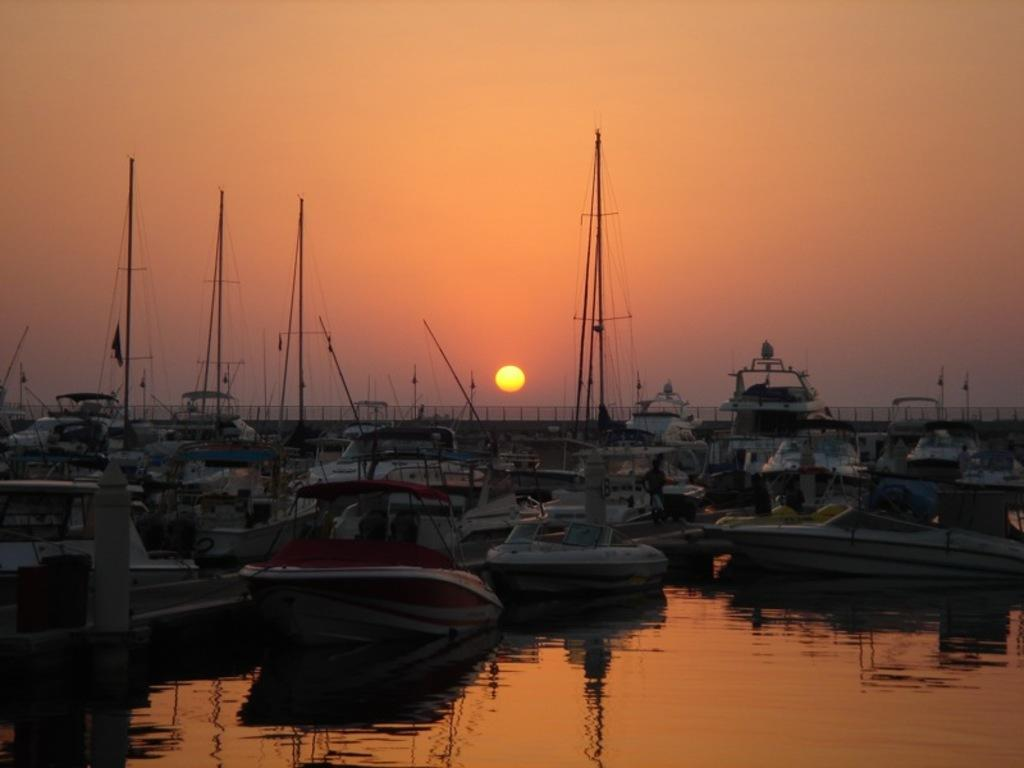What type of body of water is present in the image? There is a lake in the image. What is on the lake in the image? There are boats on the lake. What can be seen in the sky in the image? The sky is visible in the image. What celestial body is observable in the sky in the image? The sun is observable in the sky. What type of appliance is being used to measure the depth of the lake in the image? There is no appliance or measurement activity present in the image; it simply shows a lake with boats on it and the sky with the sun visible. 